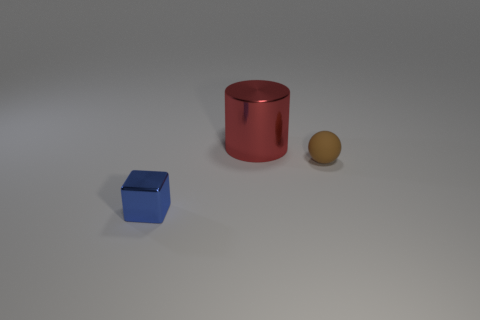Are there any other things that have the same size as the red cylinder?
Offer a very short reply. No. Is there anything else that is the same shape as the tiny metallic thing?
Your answer should be very brief. No. What shape is the rubber thing that is the same size as the blue metal thing?
Make the answer very short. Sphere. Is the number of yellow shiny cylinders less than the number of small blue things?
Your answer should be very brief. Yes. There is a shiny thing on the left side of the red metal cylinder; does it have the same size as the metal thing that is behind the tiny brown sphere?
Offer a terse response. No. What number of objects are either blue things or tiny gray rubber cubes?
Give a very brief answer. 1. There is a metallic object that is behind the brown rubber sphere; what is its size?
Offer a very short reply. Large. What number of objects are behind the tiny object that is on the left side of the object that is right of the metallic cylinder?
Ensure brevity in your answer.  2. How many tiny objects are on the left side of the tiny brown matte object and to the right of the blue metallic thing?
Make the answer very short. 0. There is a tiny object behind the block; what shape is it?
Your response must be concise. Sphere. 